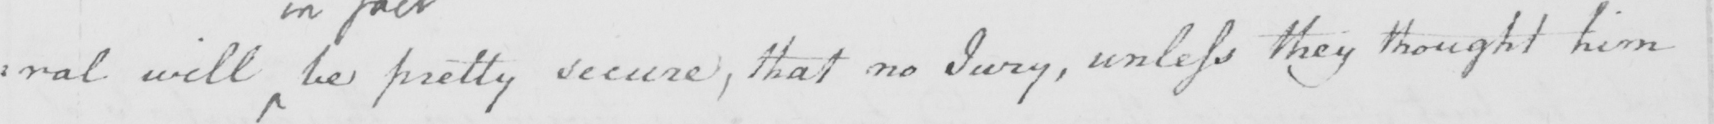Transcribe the text shown in this historical manuscript line. : ral will be pretty secure , that no Jury , unless they thought him 